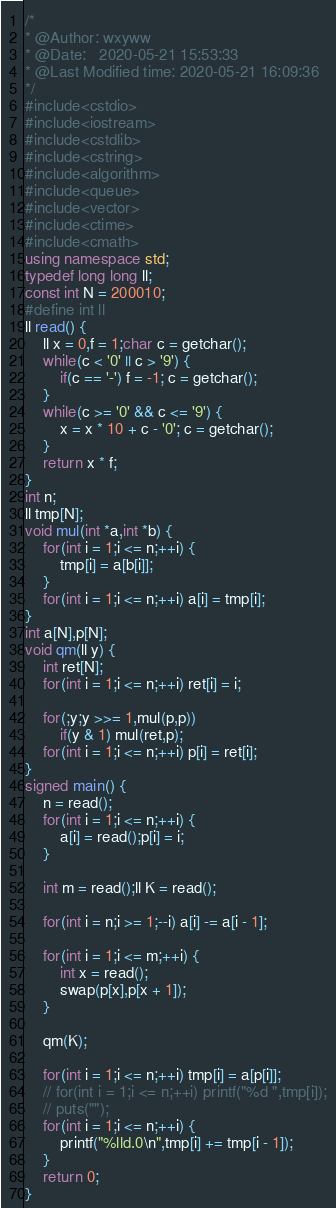Convert code to text. <code><loc_0><loc_0><loc_500><loc_500><_C++_>/*
* @Author: wxyww
* @Date:   2020-05-21 15:53:33
* @Last Modified time: 2020-05-21 16:09:36
*/
#include<cstdio>
#include<iostream>
#include<cstdlib>
#include<cstring>
#include<algorithm>
#include<queue>
#include<vector>
#include<ctime>
#include<cmath>
using namespace std;
typedef long long ll;
const int N = 200010;
#define int ll
ll read() {
	ll x = 0,f = 1;char c = getchar();
	while(c < '0' || c > '9') {
		if(c == '-') f = -1; c = getchar();
	}
	while(c >= '0' && c <= '9') {
		x = x * 10 + c - '0'; c = getchar();
	}
	return x * f;
}
int n;
ll tmp[N];
void mul(int *a,int *b) {
	for(int i = 1;i <= n;++i) {
		tmp[i] = a[b[i]];
	}
	for(int i = 1;i <= n;++i) a[i] = tmp[i];
}
int a[N],p[N];
void qm(ll y) {
	int ret[N];
	for(int i = 1;i <= n;++i) ret[i] = i;

	for(;y;y >>= 1,mul(p,p))
		if(y & 1) mul(ret,p);
	for(int i = 1;i <= n;++i) p[i] = ret[i];
}
signed main() {
	n = read();
	for(int i = 1;i <= n;++i) {
		a[i] = read();p[i] = i;
	}
	
	int m = read();ll K = read();
	
	for(int i = n;i >= 1;--i) a[i] -= a[i - 1];
	
	for(int i = 1;i <= m;++i) {
		int x = read();
		swap(p[x],p[x + 1]);
	}

	qm(K);

	for(int i = 1;i <= n;++i) tmp[i] = a[p[i]];
	// for(int i = 1;i <= n;++i) printf("%d ",tmp[i]);
	// puts("");
	for(int i = 1;i <= n;++i) {
		printf("%lld.0\n",tmp[i] += tmp[i - 1]);
	}
	return 0;
}</code> 